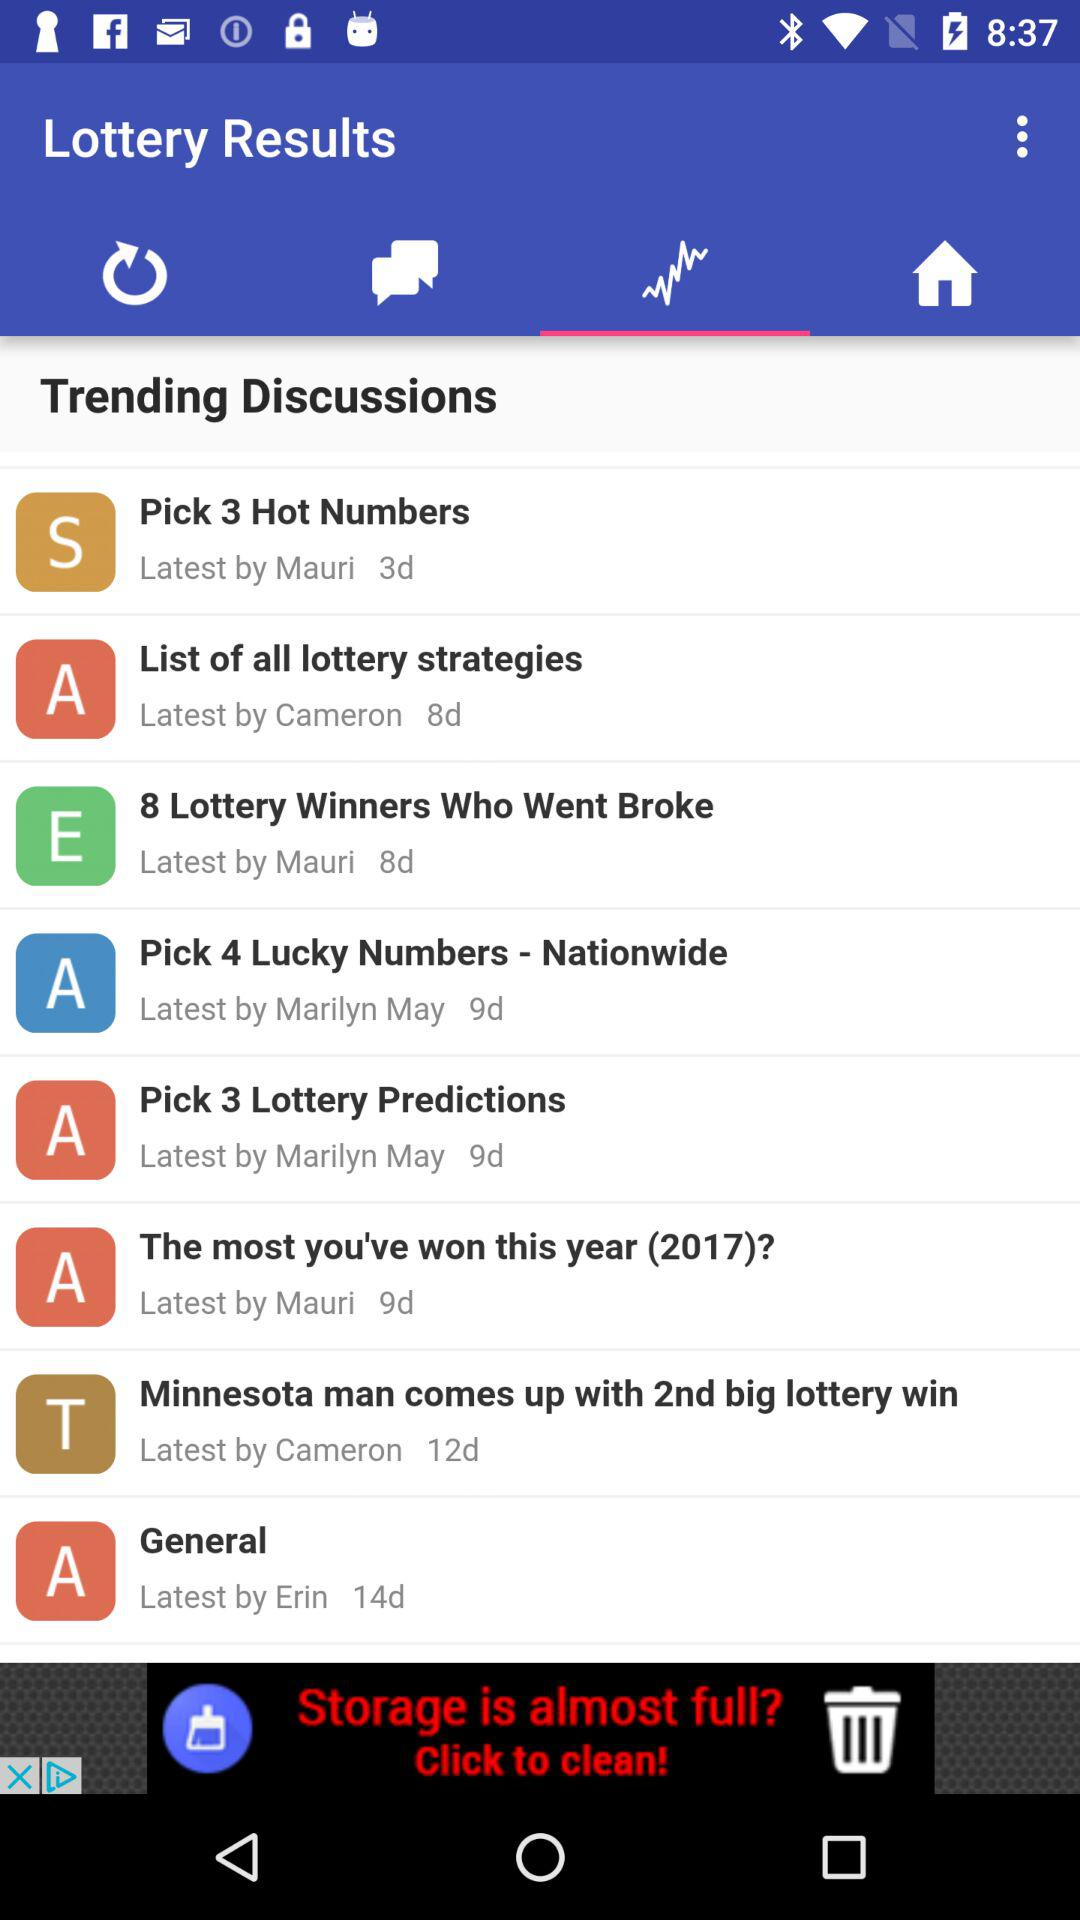What time was "Pick 3 Hot Numbers" posted?
When the provided information is insufficient, respond with <no answer>. <no answer> 